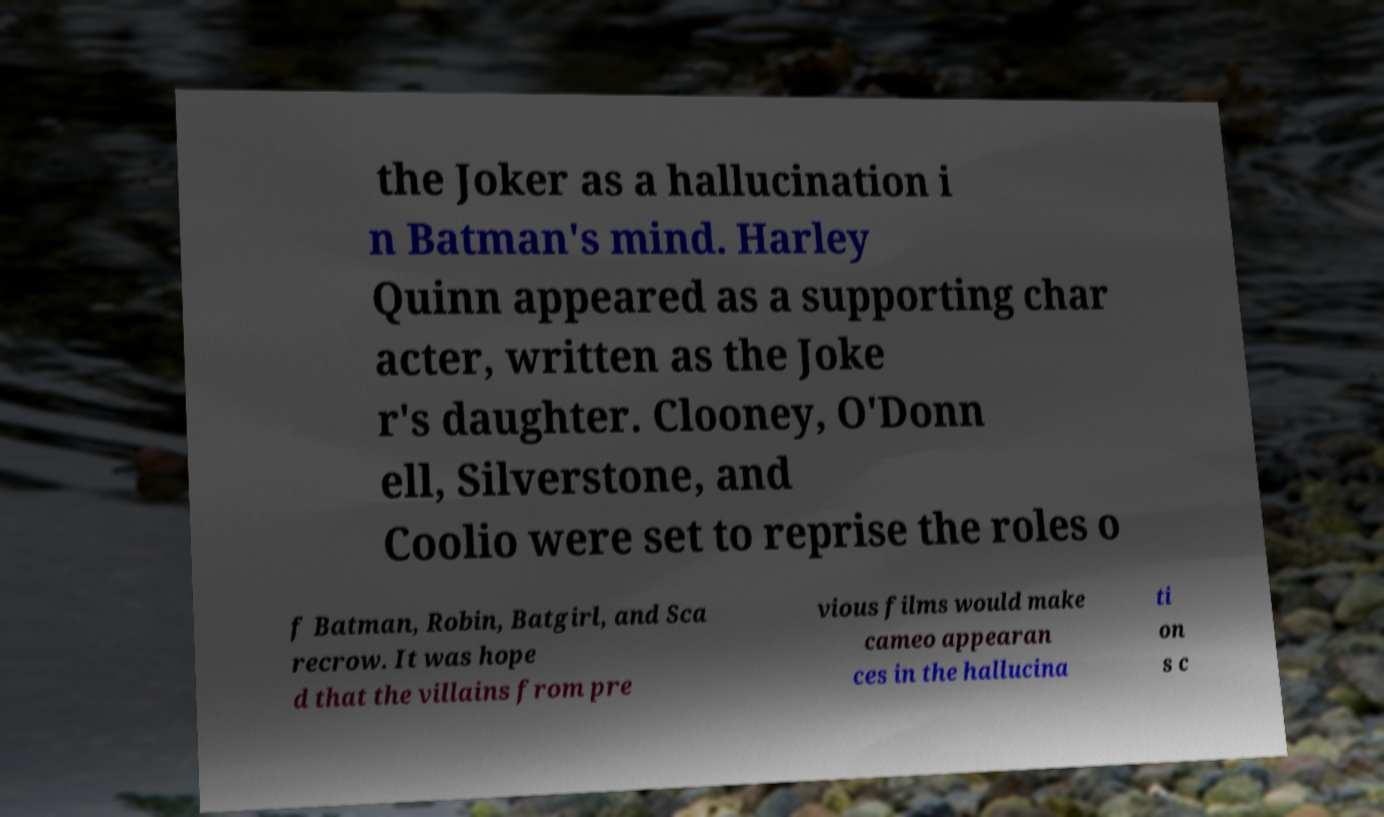Please identify and transcribe the text found in this image. the Joker as a hallucination i n Batman's mind. Harley Quinn appeared as a supporting char acter, written as the Joke r's daughter. Clooney, O'Donn ell, Silverstone, and Coolio were set to reprise the roles o f Batman, Robin, Batgirl, and Sca recrow. It was hope d that the villains from pre vious films would make cameo appearan ces in the hallucina ti on s c 